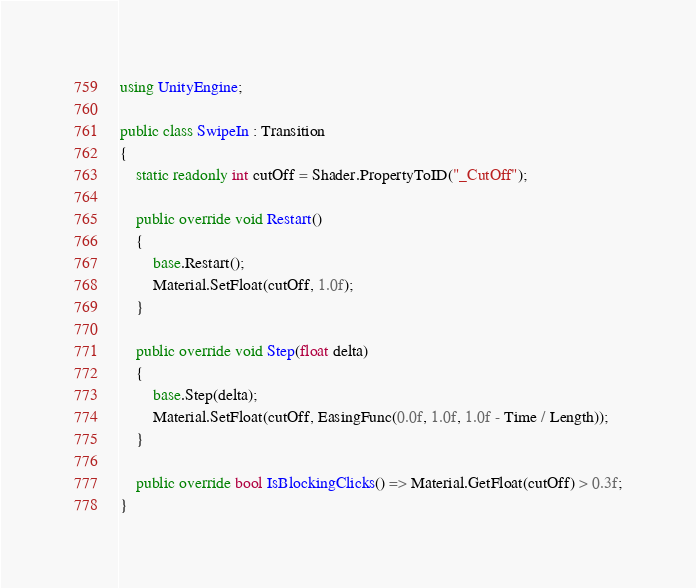Convert code to text. <code><loc_0><loc_0><loc_500><loc_500><_C#_>using UnityEngine;

public class SwipeIn : Transition
{
	static readonly int cutOff = Shader.PropertyToID("_CutOff");

	public override void Restart()
	{
		base.Restart();
		Material.SetFloat(cutOff, 1.0f);
	}

	public override void Step(float delta)
	{
		base.Step(delta);
		Material.SetFloat(cutOff, EasingFunc(0.0f, 1.0f, 1.0f - Time / Length));
	}

	public override bool IsBlockingClicks() => Material.GetFloat(cutOff) > 0.3f;
}
</code> 